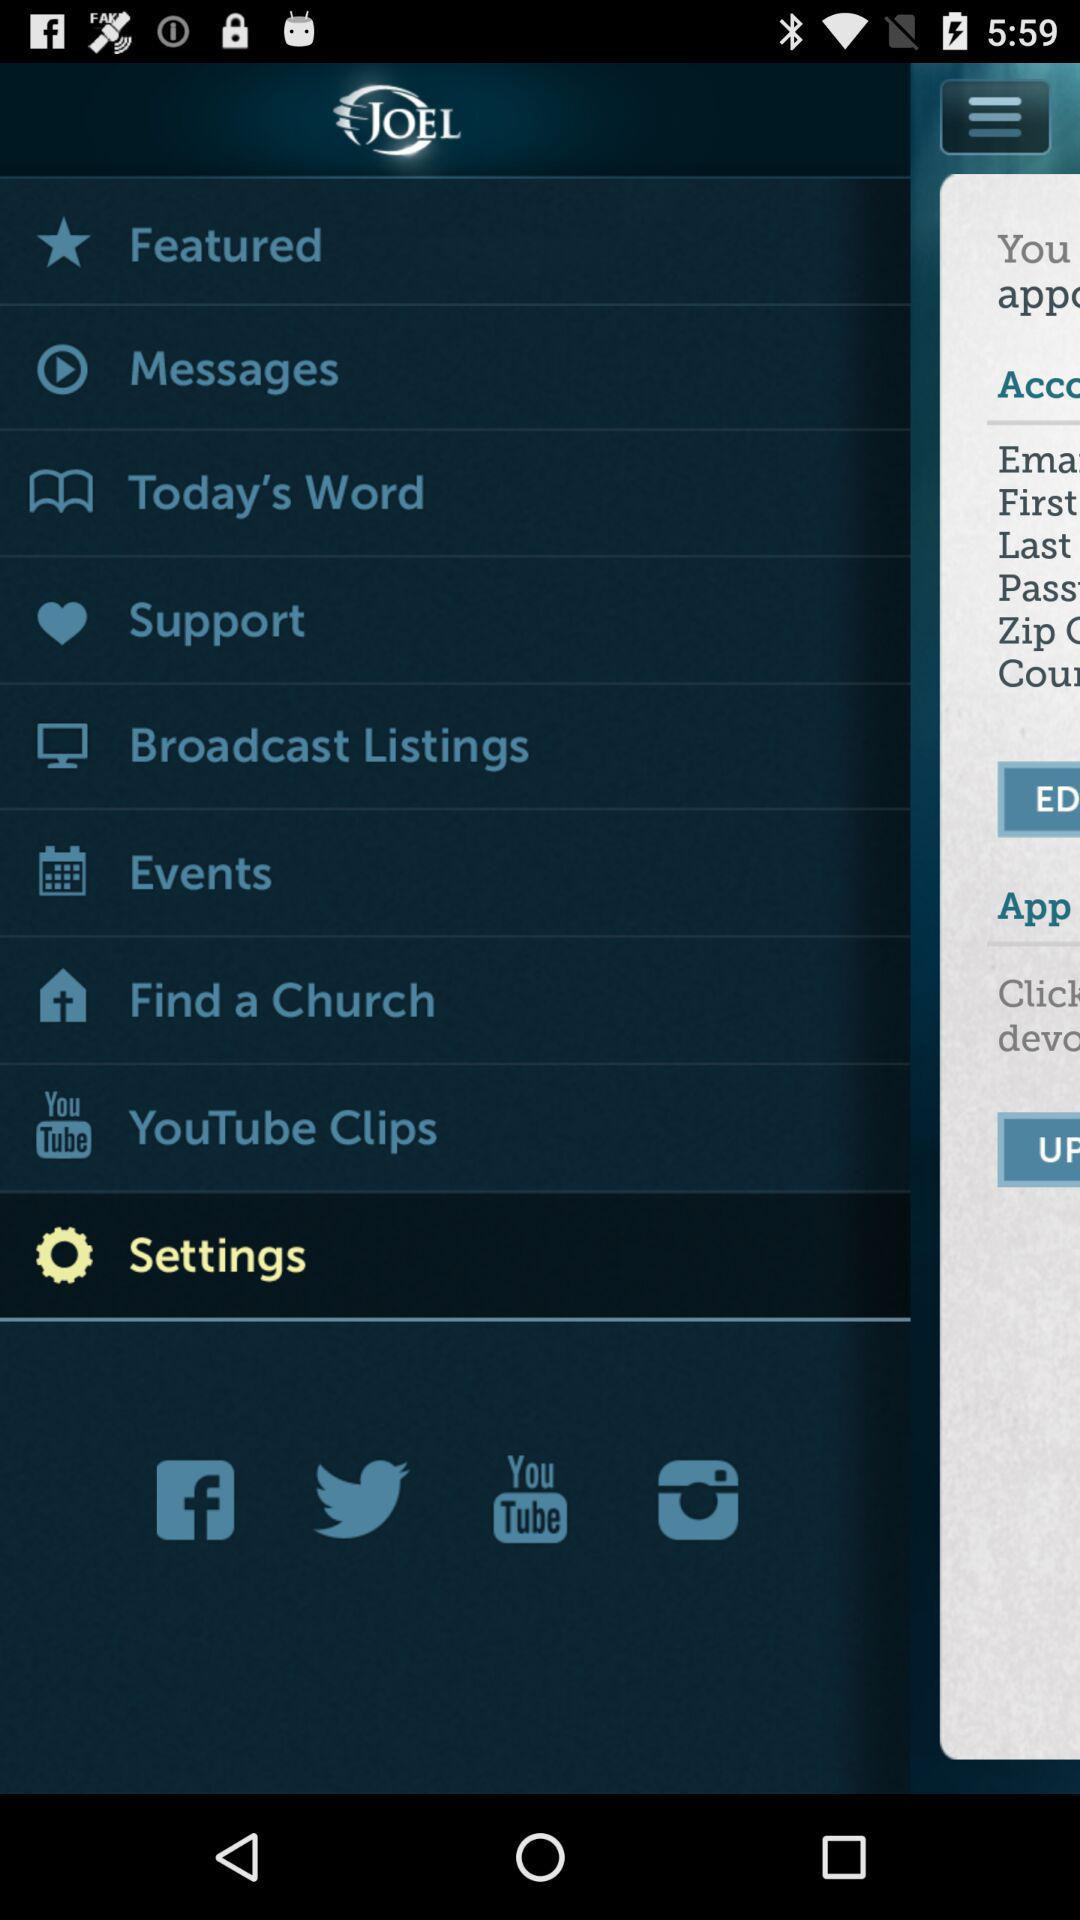What is the application name? The application name is "JOEL". 